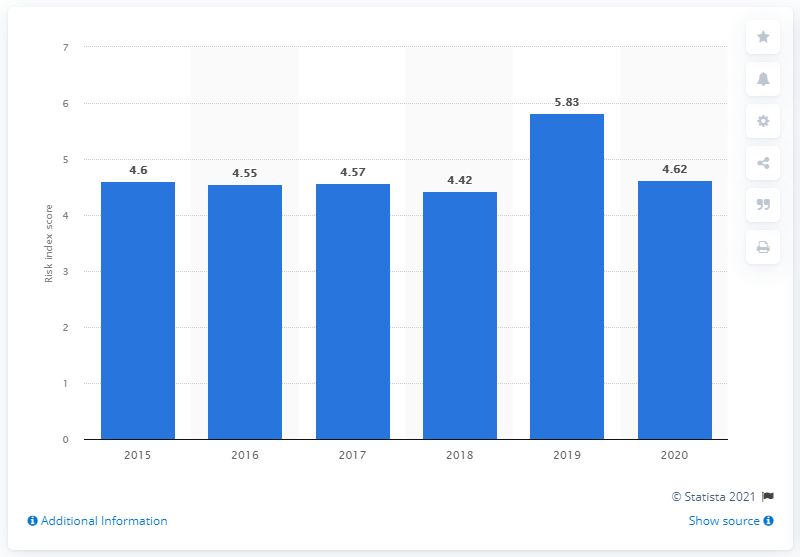Specify some key components in this picture. Colombia's risk of money laundering and terrorist financing in 2020 was estimated to be 4.62. 